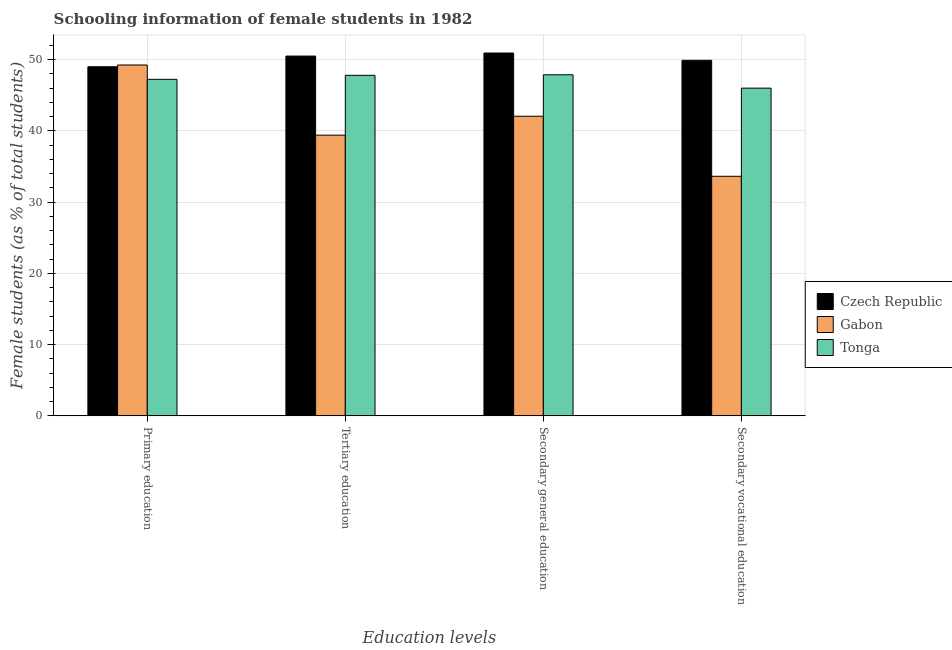How many bars are there on the 3rd tick from the left?
Provide a succinct answer. 3. What is the label of the 4th group of bars from the left?
Ensure brevity in your answer.  Secondary vocational education. What is the percentage of female students in secondary vocational education in Tonga?
Provide a short and direct response. 46. Across all countries, what is the maximum percentage of female students in secondary education?
Offer a terse response. 50.93. Across all countries, what is the minimum percentage of female students in secondary education?
Make the answer very short. 42.05. In which country was the percentage of female students in primary education maximum?
Make the answer very short. Gabon. In which country was the percentage of female students in tertiary education minimum?
Give a very brief answer. Gabon. What is the total percentage of female students in tertiary education in the graph?
Your answer should be compact. 137.7. What is the difference between the percentage of female students in primary education in Czech Republic and that in Tonga?
Your answer should be compact. 1.76. What is the difference between the percentage of female students in tertiary education in Gabon and the percentage of female students in primary education in Tonga?
Provide a succinct answer. -7.84. What is the average percentage of female students in primary education per country?
Offer a very short reply. 48.49. What is the difference between the percentage of female students in secondary vocational education and percentage of female students in tertiary education in Tonga?
Offer a terse response. -1.8. What is the ratio of the percentage of female students in secondary education in Tonga to that in Czech Republic?
Provide a short and direct response. 0.94. Is the difference between the percentage of female students in secondary vocational education in Czech Republic and Tonga greater than the difference between the percentage of female students in tertiary education in Czech Republic and Tonga?
Provide a succinct answer. Yes. What is the difference between the highest and the second highest percentage of female students in tertiary education?
Provide a succinct answer. 2.7. What is the difference between the highest and the lowest percentage of female students in secondary education?
Offer a very short reply. 8.87. In how many countries, is the percentage of female students in secondary vocational education greater than the average percentage of female students in secondary vocational education taken over all countries?
Make the answer very short. 2. Is it the case that in every country, the sum of the percentage of female students in primary education and percentage of female students in secondary education is greater than the sum of percentage of female students in secondary vocational education and percentage of female students in tertiary education?
Provide a succinct answer. No. What does the 2nd bar from the left in Tertiary education represents?
Provide a succinct answer. Gabon. What does the 2nd bar from the right in Tertiary education represents?
Provide a short and direct response. Gabon. How many bars are there?
Ensure brevity in your answer.  12. How many countries are there in the graph?
Your answer should be very brief. 3. Does the graph contain any zero values?
Give a very brief answer. No. Does the graph contain grids?
Make the answer very short. Yes. Where does the legend appear in the graph?
Keep it short and to the point. Center right. How many legend labels are there?
Your answer should be very brief. 3. What is the title of the graph?
Your answer should be compact. Schooling information of female students in 1982. What is the label or title of the X-axis?
Provide a succinct answer. Education levels. What is the label or title of the Y-axis?
Ensure brevity in your answer.  Female students (as % of total students). What is the Female students (as % of total students) of Czech Republic in Primary education?
Your response must be concise. 49. What is the Female students (as % of total students) in Gabon in Primary education?
Keep it short and to the point. 49.25. What is the Female students (as % of total students) of Tonga in Primary education?
Offer a terse response. 47.24. What is the Female students (as % of total students) in Czech Republic in Tertiary education?
Provide a short and direct response. 50.5. What is the Female students (as % of total students) in Gabon in Tertiary education?
Your response must be concise. 39.4. What is the Female students (as % of total students) of Tonga in Tertiary education?
Ensure brevity in your answer.  47.8. What is the Female students (as % of total students) in Czech Republic in Secondary general education?
Offer a very short reply. 50.93. What is the Female students (as % of total students) in Gabon in Secondary general education?
Keep it short and to the point. 42.05. What is the Female students (as % of total students) in Tonga in Secondary general education?
Ensure brevity in your answer.  47.88. What is the Female students (as % of total students) of Czech Republic in Secondary vocational education?
Your answer should be very brief. 49.9. What is the Female students (as % of total students) of Gabon in Secondary vocational education?
Offer a terse response. 33.63. What is the Female students (as % of total students) of Tonga in Secondary vocational education?
Give a very brief answer. 46. Across all Education levels, what is the maximum Female students (as % of total students) of Czech Republic?
Keep it short and to the point. 50.93. Across all Education levels, what is the maximum Female students (as % of total students) of Gabon?
Give a very brief answer. 49.25. Across all Education levels, what is the maximum Female students (as % of total students) of Tonga?
Keep it short and to the point. 47.88. Across all Education levels, what is the minimum Female students (as % of total students) of Czech Republic?
Make the answer very short. 49. Across all Education levels, what is the minimum Female students (as % of total students) of Gabon?
Offer a terse response. 33.63. Across all Education levels, what is the minimum Female students (as % of total students) in Tonga?
Offer a very short reply. 46. What is the total Female students (as % of total students) of Czech Republic in the graph?
Your response must be concise. 200.33. What is the total Female students (as % of total students) in Gabon in the graph?
Make the answer very short. 164.33. What is the total Female students (as % of total students) in Tonga in the graph?
Make the answer very short. 188.91. What is the difference between the Female students (as % of total students) of Czech Republic in Primary education and that in Tertiary education?
Offer a very short reply. -1.5. What is the difference between the Female students (as % of total students) of Gabon in Primary education and that in Tertiary education?
Give a very brief answer. 9.85. What is the difference between the Female students (as % of total students) of Tonga in Primary education and that in Tertiary education?
Give a very brief answer. -0.56. What is the difference between the Female students (as % of total students) in Czech Republic in Primary education and that in Secondary general education?
Your response must be concise. -1.93. What is the difference between the Female students (as % of total students) of Gabon in Primary education and that in Secondary general education?
Make the answer very short. 7.19. What is the difference between the Female students (as % of total students) in Tonga in Primary education and that in Secondary general education?
Ensure brevity in your answer.  -0.64. What is the difference between the Female students (as % of total students) of Czech Republic in Primary education and that in Secondary vocational education?
Offer a very short reply. -0.9. What is the difference between the Female students (as % of total students) of Gabon in Primary education and that in Secondary vocational education?
Make the answer very short. 15.62. What is the difference between the Female students (as % of total students) of Tonga in Primary education and that in Secondary vocational education?
Offer a very short reply. 1.24. What is the difference between the Female students (as % of total students) of Czech Republic in Tertiary education and that in Secondary general education?
Provide a short and direct response. -0.43. What is the difference between the Female students (as % of total students) in Gabon in Tertiary education and that in Secondary general education?
Your response must be concise. -2.66. What is the difference between the Female students (as % of total students) in Tonga in Tertiary education and that in Secondary general education?
Provide a short and direct response. -0.08. What is the difference between the Female students (as % of total students) in Czech Republic in Tertiary education and that in Secondary vocational education?
Your answer should be compact. 0.6. What is the difference between the Female students (as % of total students) of Gabon in Tertiary education and that in Secondary vocational education?
Offer a terse response. 5.77. What is the difference between the Female students (as % of total students) in Tonga in Tertiary education and that in Secondary vocational education?
Ensure brevity in your answer.  1.8. What is the difference between the Female students (as % of total students) in Czech Republic in Secondary general education and that in Secondary vocational education?
Your answer should be compact. 1.03. What is the difference between the Female students (as % of total students) of Gabon in Secondary general education and that in Secondary vocational education?
Offer a terse response. 8.43. What is the difference between the Female students (as % of total students) in Tonga in Secondary general education and that in Secondary vocational education?
Offer a very short reply. 1.88. What is the difference between the Female students (as % of total students) of Czech Republic in Primary education and the Female students (as % of total students) of Gabon in Tertiary education?
Your answer should be very brief. 9.6. What is the difference between the Female students (as % of total students) of Czech Republic in Primary education and the Female students (as % of total students) of Tonga in Tertiary education?
Your answer should be compact. 1.2. What is the difference between the Female students (as % of total students) in Gabon in Primary education and the Female students (as % of total students) in Tonga in Tertiary education?
Your response must be concise. 1.45. What is the difference between the Female students (as % of total students) in Czech Republic in Primary education and the Female students (as % of total students) in Gabon in Secondary general education?
Make the answer very short. 6.95. What is the difference between the Female students (as % of total students) in Czech Republic in Primary education and the Female students (as % of total students) in Tonga in Secondary general education?
Make the answer very short. 1.12. What is the difference between the Female students (as % of total students) in Gabon in Primary education and the Female students (as % of total students) in Tonga in Secondary general education?
Your response must be concise. 1.37. What is the difference between the Female students (as % of total students) in Czech Republic in Primary education and the Female students (as % of total students) in Gabon in Secondary vocational education?
Offer a terse response. 15.37. What is the difference between the Female students (as % of total students) in Czech Republic in Primary education and the Female students (as % of total students) in Tonga in Secondary vocational education?
Keep it short and to the point. 3. What is the difference between the Female students (as % of total students) in Gabon in Primary education and the Female students (as % of total students) in Tonga in Secondary vocational education?
Your answer should be compact. 3.25. What is the difference between the Female students (as % of total students) in Czech Republic in Tertiary education and the Female students (as % of total students) in Gabon in Secondary general education?
Your answer should be very brief. 8.45. What is the difference between the Female students (as % of total students) in Czech Republic in Tertiary education and the Female students (as % of total students) in Tonga in Secondary general education?
Offer a very short reply. 2.62. What is the difference between the Female students (as % of total students) of Gabon in Tertiary education and the Female students (as % of total students) of Tonga in Secondary general education?
Give a very brief answer. -8.48. What is the difference between the Female students (as % of total students) of Czech Republic in Tertiary education and the Female students (as % of total students) of Gabon in Secondary vocational education?
Offer a terse response. 16.87. What is the difference between the Female students (as % of total students) in Czech Republic in Tertiary education and the Female students (as % of total students) in Tonga in Secondary vocational education?
Offer a very short reply. 4.5. What is the difference between the Female students (as % of total students) in Gabon in Tertiary education and the Female students (as % of total students) in Tonga in Secondary vocational education?
Give a very brief answer. -6.6. What is the difference between the Female students (as % of total students) of Czech Republic in Secondary general education and the Female students (as % of total students) of Gabon in Secondary vocational education?
Ensure brevity in your answer.  17.3. What is the difference between the Female students (as % of total students) of Czech Republic in Secondary general education and the Female students (as % of total students) of Tonga in Secondary vocational education?
Your answer should be very brief. 4.93. What is the difference between the Female students (as % of total students) of Gabon in Secondary general education and the Female students (as % of total students) of Tonga in Secondary vocational education?
Provide a short and direct response. -3.94. What is the average Female students (as % of total students) of Czech Republic per Education levels?
Provide a short and direct response. 50.08. What is the average Female students (as % of total students) of Gabon per Education levels?
Ensure brevity in your answer.  41.08. What is the average Female students (as % of total students) of Tonga per Education levels?
Provide a short and direct response. 47.23. What is the difference between the Female students (as % of total students) in Czech Republic and Female students (as % of total students) in Gabon in Primary education?
Keep it short and to the point. -0.25. What is the difference between the Female students (as % of total students) of Czech Republic and Female students (as % of total students) of Tonga in Primary education?
Keep it short and to the point. 1.76. What is the difference between the Female students (as % of total students) in Gabon and Female students (as % of total students) in Tonga in Primary education?
Make the answer very short. 2.01. What is the difference between the Female students (as % of total students) in Czech Republic and Female students (as % of total students) in Gabon in Tertiary education?
Give a very brief answer. 11.1. What is the difference between the Female students (as % of total students) of Czech Republic and Female students (as % of total students) of Tonga in Tertiary education?
Your response must be concise. 2.71. What is the difference between the Female students (as % of total students) of Gabon and Female students (as % of total students) of Tonga in Tertiary education?
Provide a short and direct response. -8.4. What is the difference between the Female students (as % of total students) in Czech Republic and Female students (as % of total students) in Gabon in Secondary general education?
Provide a short and direct response. 8.87. What is the difference between the Female students (as % of total students) in Czech Republic and Female students (as % of total students) in Tonga in Secondary general education?
Give a very brief answer. 3.05. What is the difference between the Female students (as % of total students) in Gabon and Female students (as % of total students) in Tonga in Secondary general education?
Your response must be concise. -5.82. What is the difference between the Female students (as % of total students) of Czech Republic and Female students (as % of total students) of Gabon in Secondary vocational education?
Give a very brief answer. 16.28. What is the difference between the Female students (as % of total students) in Czech Republic and Female students (as % of total students) in Tonga in Secondary vocational education?
Ensure brevity in your answer.  3.91. What is the difference between the Female students (as % of total students) in Gabon and Female students (as % of total students) in Tonga in Secondary vocational education?
Give a very brief answer. -12.37. What is the ratio of the Female students (as % of total students) in Czech Republic in Primary education to that in Tertiary education?
Your response must be concise. 0.97. What is the ratio of the Female students (as % of total students) of Gabon in Primary education to that in Tertiary education?
Offer a very short reply. 1.25. What is the ratio of the Female students (as % of total students) in Tonga in Primary education to that in Tertiary education?
Provide a short and direct response. 0.99. What is the ratio of the Female students (as % of total students) of Czech Republic in Primary education to that in Secondary general education?
Your answer should be compact. 0.96. What is the ratio of the Female students (as % of total students) in Gabon in Primary education to that in Secondary general education?
Your answer should be very brief. 1.17. What is the ratio of the Female students (as % of total students) in Tonga in Primary education to that in Secondary general education?
Provide a short and direct response. 0.99. What is the ratio of the Female students (as % of total students) in Czech Republic in Primary education to that in Secondary vocational education?
Provide a short and direct response. 0.98. What is the ratio of the Female students (as % of total students) of Gabon in Primary education to that in Secondary vocational education?
Your answer should be compact. 1.46. What is the ratio of the Female students (as % of total students) in Tonga in Primary education to that in Secondary vocational education?
Keep it short and to the point. 1.03. What is the ratio of the Female students (as % of total students) in Czech Republic in Tertiary education to that in Secondary general education?
Keep it short and to the point. 0.99. What is the ratio of the Female students (as % of total students) in Gabon in Tertiary education to that in Secondary general education?
Make the answer very short. 0.94. What is the ratio of the Female students (as % of total students) of Gabon in Tertiary education to that in Secondary vocational education?
Provide a succinct answer. 1.17. What is the ratio of the Female students (as % of total students) of Tonga in Tertiary education to that in Secondary vocational education?
Provide a succinct answer. 1.04. What is the ratio of the Female students (as % of total students) of Czech Republic in Secondary general education to that in Secondary vocational education?
Your answer should be compact. 1.02. What is the ratio of the Female students (as % of total students) in Gabon in Secondary general education to that in Secondary vocational education?
Offer a terse response. 1.25. What is the ratio of the Female students (as % of total students) in Tonga in Secondary general education to that in Secondary vocational education?
Provide a succinct answer. 1.04. What is the difference between the highest and the second highest Female students (as % of total students) in Czech Republic?
Your answer should be very brief. 0.43. What is the difference between the highest and the second highest Female students (as % of total students) of Gabon?
Provide a succinct answer. 7.19. What is the difference between the highest and the second highest Female students (as % of total students) of Tonga?
Your answer should be compact. 0.08. What is the difference between the highest and the lowest Female students (as % of total students) in Czech Republic?
Your answer should be very brief. 1.93. What is the difference between the highest and the lowest Female students (as % of total students) of Gabon?
Provide a short and direct response. 15.62. What is the difference between the highest and the lowest Female students (as % of total students) of Tonga?
Make the answer very short. 1.88. 